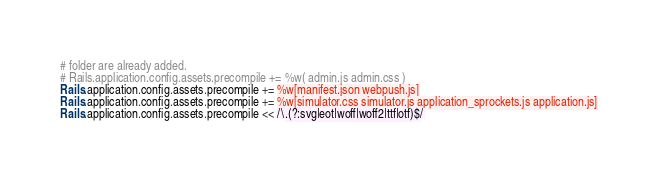<code> <loc_0><loc_0><loc_500><loc_500><_Ruby_># folder are already added.
# Rails.application.config.assets.precompile += %w( admin.js admin.css )
Rails.application.config.assets.precompile += %w[manifest.json webpush.js]
Rails.application.config.assets.precompile += %w[simulator.css simulator.js application_sprockets.js application.js]
Rails.application.config.assets.precompile << /\.(?:svg|eot|woff|woff2|ttf|otf)$/
</code> 